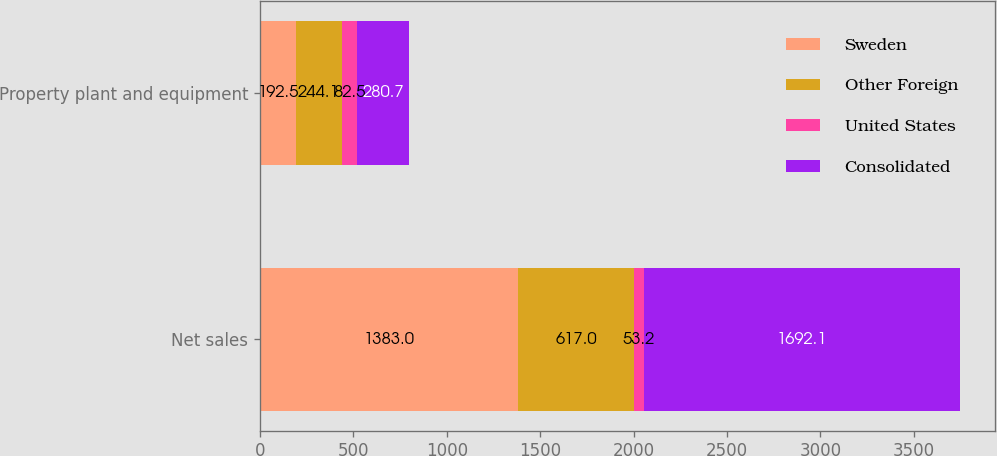Convert chart to OTSL. <chart><loc_0><loc_0><loc_500><loc_500><stacked_bar_chart><ecel><fcel>Net sales<fcel>Property plant and equipment<nl><fcel>Sweden<fcel>1383<fcel>192.5<nl><fcel>Other Foreign<fcel>617<fcel>244.1<nl><fcel>United States<fcel>53.2<fcel>82.5<nl><fcel>Consolidated<fcel>1692.1<fcel>280.7<nl></chart> 